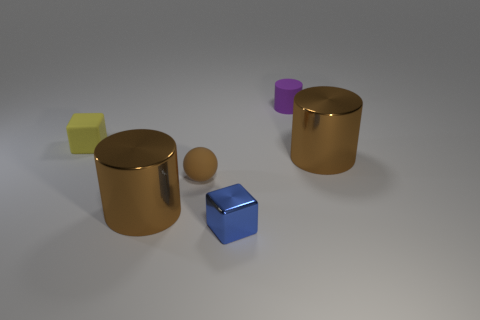What could be the function of these objects if they were real-life items? If these objects were to exist in real life, it's possible they could serve as decorative pieces due to their aesthetically pleasing forms and finishes. Alternatively, given their geometric shapes, they might be used in educational settings to help teach concepts of volume, geometry, or spatial reasoning. The reflective surfaces of the metallic objects could also serve a purpose in lighting design, being used to reflect or diffuse light in a space. 